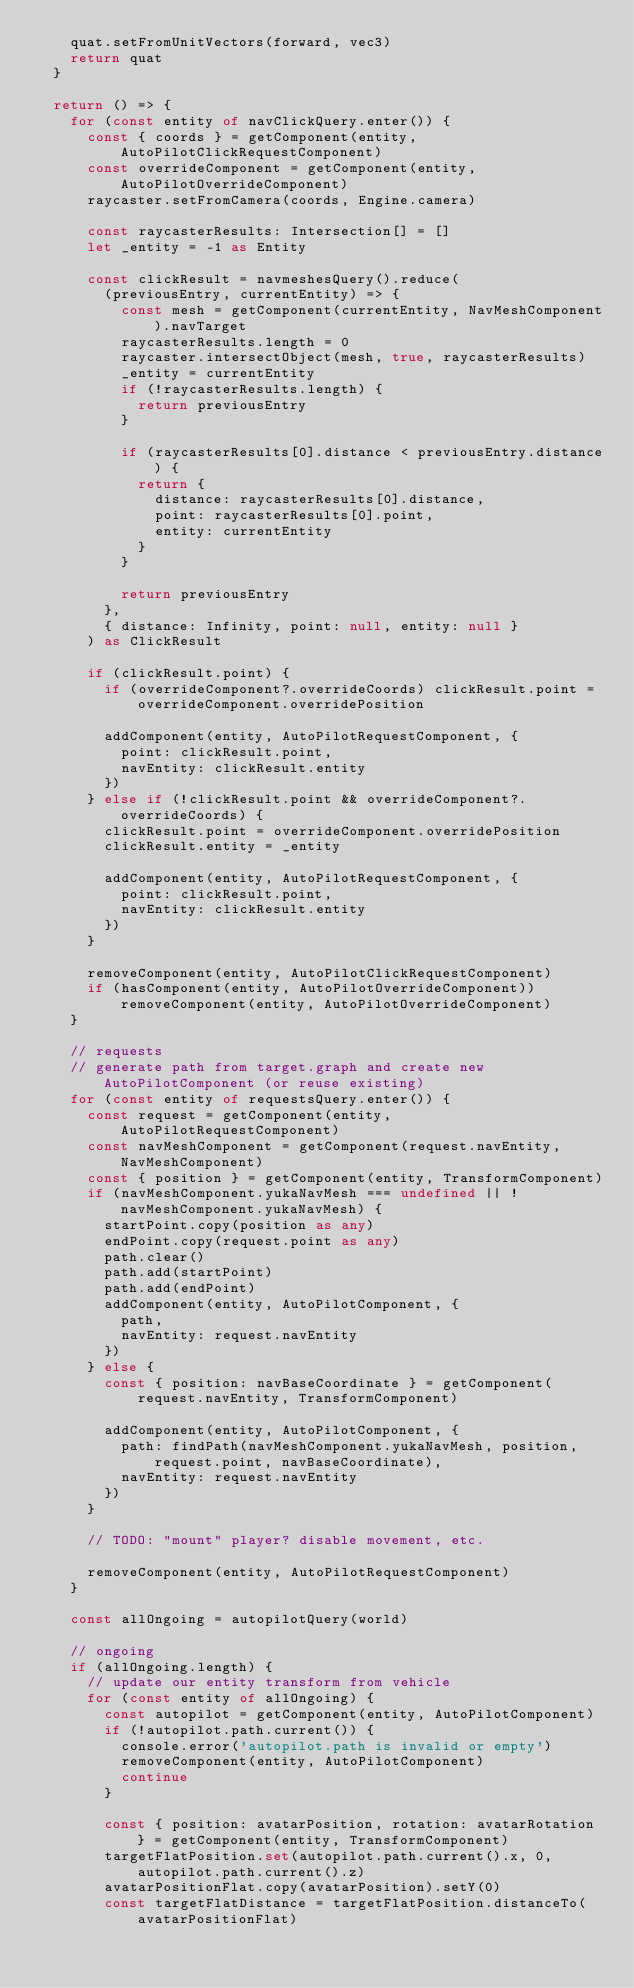Convert code to text. <code><loc_0><loc_0><loc_500><loc_500><_TypeScript_>    quat.setFromUnitVectors(forward, vec3)
    return quat
  }

  return () => {
    for (const entity of navClickQuery.enter()) {
      const { coords } = getComponent(entity, AutoPilotClickRequestComponent)
      const overrideComponent = getComponent(entity, AutoPilotOverrideComponent)
      raycaster.setFromCamera(coords, Engine.camera)

      const raycasterResults: Intersection[] = []
      let _entity = -1 as Entity

      const clickResult = navmeshesQuery().reduce(
        (previousEntry, currentEntity) => {
          const mesh = getComponent(currentEntity, NavMeshComponent).navTarget
          raycasterResults.length = 0
          raycaster.intersectObject(mesh, true, raycasterResults)
          _entity = currentEntity
          if (!raycasterResults.length) {
            return previousEntry
          }

          if (raycasterResults[0].distance < previousEntry.distance) {
            return {
              distance: raycasterResults[0].distance,
              point: raycasterResults[0].point,
              entity: currentEntity
            }
          }

          return previousEntry
        },
        { distance: Infinity, point: null, entity: null }
      ) as ClickResult

      if (clickResult.point) {
        if (overrideComponent?.overrideCoords) clickResult.point = overrideComponent.overridePosition

        addComponent(entity, AutoPilotRequestComponent, {
          point: clickResult.point,
          navEntity: clickResult.entity
        })
      } else if (!clickResult.point && overrideComponent?.overrideCoords) {
        clickResult.point = overrideComponent.overridePosition
        clickResult.entity = _entity

        addComponent(entity, AutoPilotRequestComponent, {
          point: clickResult.point,
          navEntity: clickResult.entity
        })
      }

      removeComponent(entity, AutoPilotClickRequestComponent)
      if (hasComponent(entity, AutoPilotOverrideComponent)) removeComponent(entity, AutoPilotOverrideComponent)
    }

    // requests
    // generate path from target.graph and create new AutoPilotComponent (or reuse existing)
    for (const entity of requestsQuery.enter()) {
      const request = getComponent(entity, AutoPilotRequestComponent)
      const navMeshComponent = getComponent(request.navEntity, NavMeshComponent)
      const { position } = getComponent(entity, TransformComponent)
      if (navMeshComponent.yukaNavMesh === undefined || !navMeshComponent.yukaNavMesh) {
        startPoint.copy(position as any)
        endPoint.copy(request.point as any)
        path.clear()
        path.add(startPoint)
        path.add(endPoint)
        addComponent(entity, AutoPilotComponent, {
          path,
          navEntity: request.navEntity
        })
      } else {
        const { position: navBaseCoordinate } = getComponent(request.navEntity, TransformComponent)

        addComponent(entity, AutoPilotComponent, {
          path: findPath(navMeshComponent.yukaNavMesh, position, request.point, navBaseCoordinate),
          navEntity: request.navEntity
        })
      }

      // TODO: "mount" player? disable movement, etc.

      removeComponent(entity, AutoPilotRequestComponent)
    }

    const allOngoing = autopilotQuery(world)

    // ongoing
    if (allOngoing.length) {
      // update our entity transform from vehicle
      for (const entity of allOngoing) {
        const autopilot = getComponent(entity, AutoPilotComponent)
        if (!autopilot.path.current()) {
          console.error('autopilot.path is invalid or empty')
          removeComponent(entity, AutoPilotComponent)
          continue
        }

        const { position: avatarPosition, rotation: avatarRotation } = getComponent(entity, TransformComponent)
        targetFlatPosition.set(autopilot.path.current().x, 0, autopilot.path.current().z)
        avatarPositionFlat.copy(avatarPosition).setY(0)
        const targetFlatDistance = targetFlatPosition.distanceTo(avatarPositionFlat)</code> 